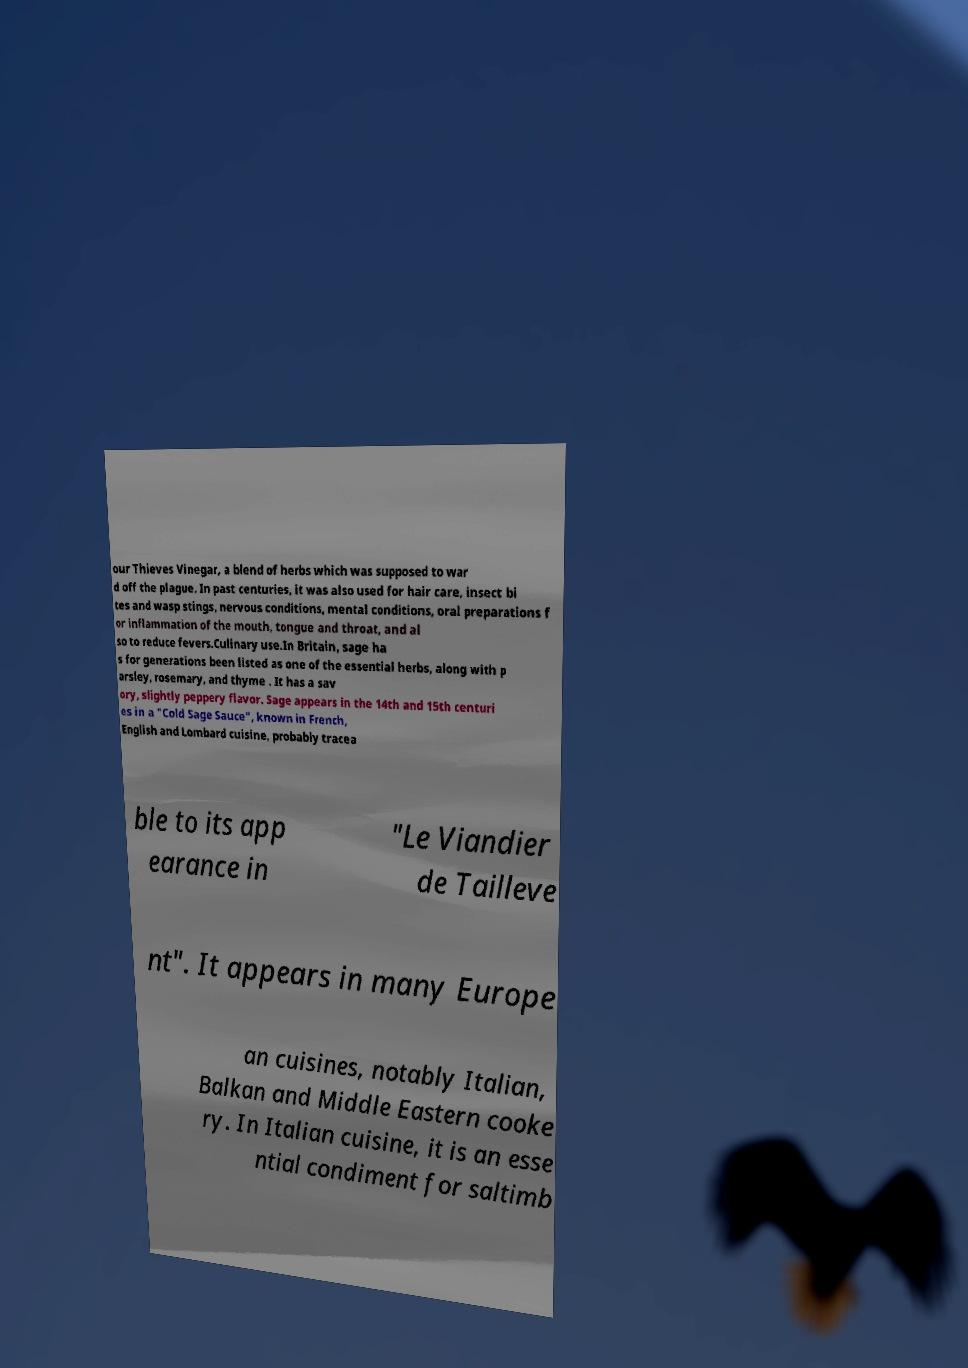Can you read and provide the text displayed in the image?This photo seems to have some interesting text. Can you extract and type it out for me? our Thieves Vinegar, a blend of herbs which was supposed to war d off the plague. In past centuries, it was also used for hair care, insect bi tes and wasp stings, nervous conditions, mental conditions, oral preparations f or inflammation of the mouth, tongue and throat, and al so to reduce fevers.Culinary use.In Britain, sage ha s for generations been listed as one of the essential herbs, along with p arsley, rosemary, and thyme . It has a sav ory, slightly peppery flavor. Sage appears in the 14th and 15th centuri es in a "Cold Sage Sauce", known in French, English and Lombard cuisine, probably tracea ble to its app earance in "Le Viandier de Tailleve nt". It appears in many Europe an cuisines, notably Italian, Balkan and Middle Eastern cooke ry. In Italian cuisine, it is an esse ntial condiment for saltimb 